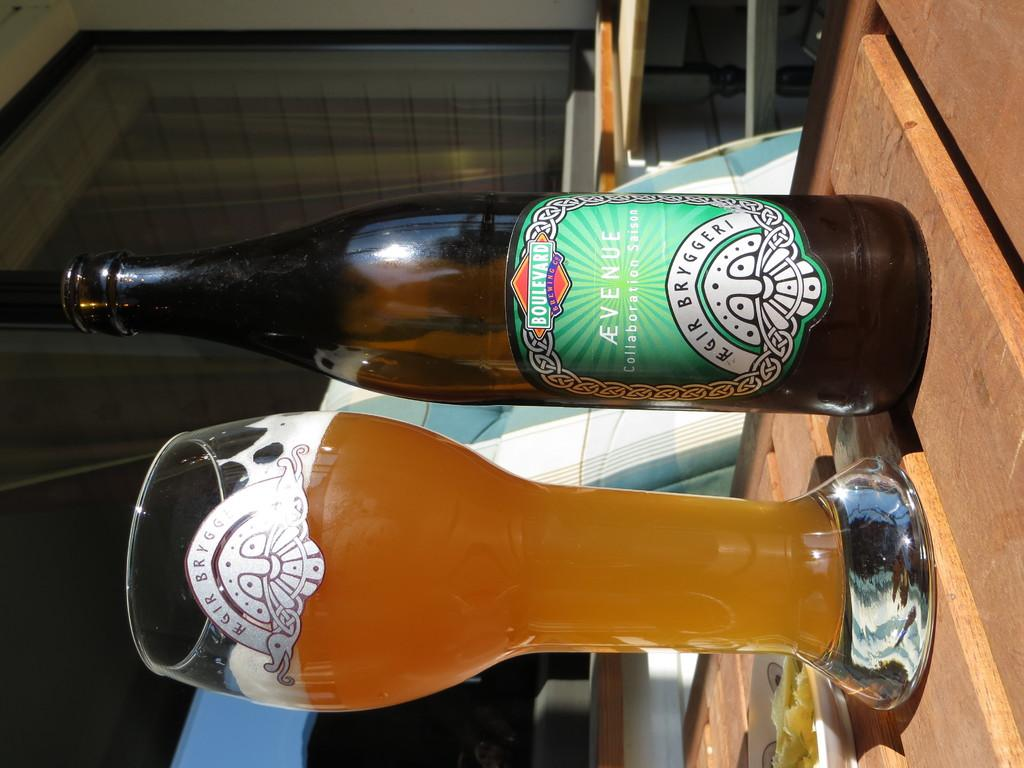<image>
Share a concise interpretation of the image provided. An Avenue beer bottle with a green label beside a beer glass filled with beer on a table top 